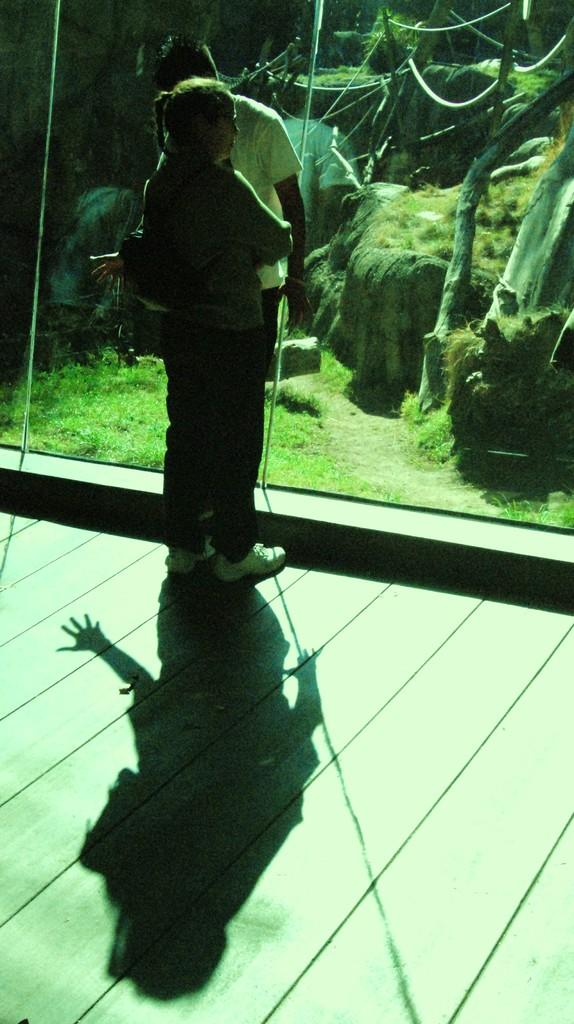How many people are present in the image? There are two persons standing in the image. Can you describe any other features in the image besides the people? Yes, there is a shadow on the floor in the image. What example of a cent can be seen in the image? There is no example of a cent present in the image. 